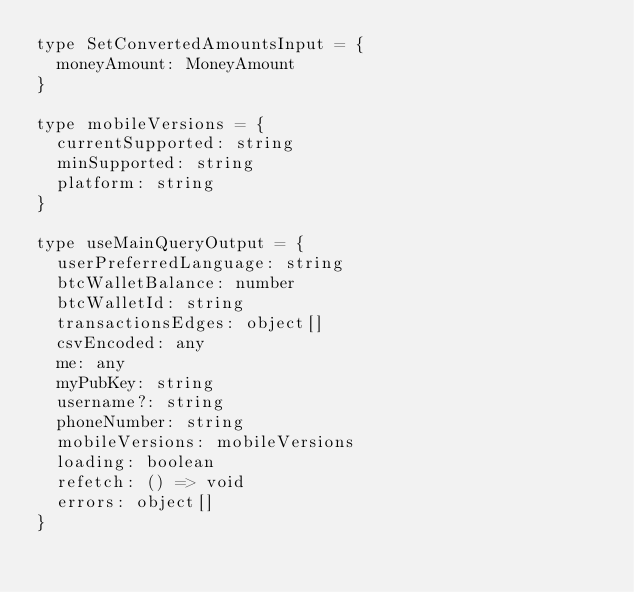Convert code to text. <code><loc_0><loc_0><loc_500><loc_500><_TypeScript_>type SetConvertedAmountsInput = {
  moneyAmount: MoneyAmount
}

type mobileVersions = {
  currentSupported: string
  minSupported: string
  platform: string
}

type useMainQueryOutput = {
  userPreferredLanguage: string
  btcWalletBalance: number
  btcWalletId: string
  transactionsEdges: object[]
  csvEncoded: any
  me: any
  myPubKey: string
  username?: string
  phoneNumber: string
  mobileVersions: mobileVersions
  loading: boolean
  refetch: () => void
  errors: object[]
}
</code> 